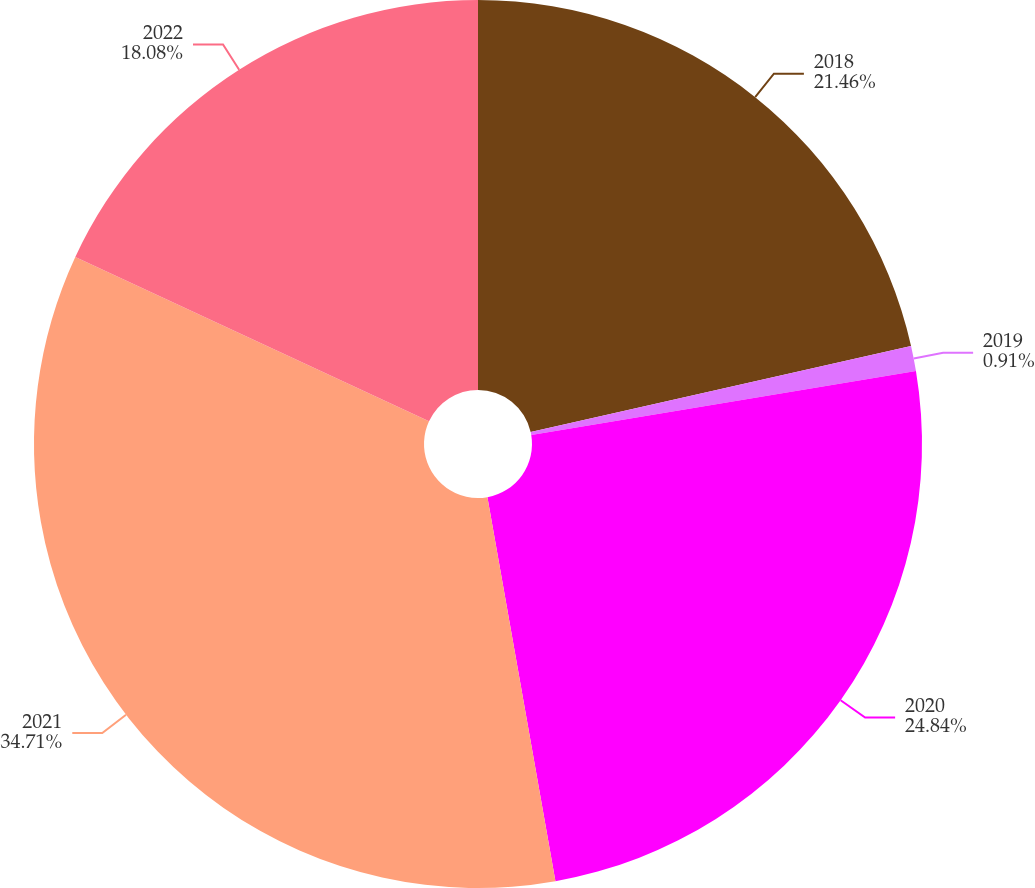Convert chart to OTSL. <chart><loc_0><loc_0><loc_500><loc_500><pie_chart><fcel>2018<fcel>2019<fcel>2020<fcel>2021<fcel>2022<nl><fcel>21.46%<fcel>0.91%<fcel>24.84%<fcel>34.71%<fcel>18.08%<nl></chart> 